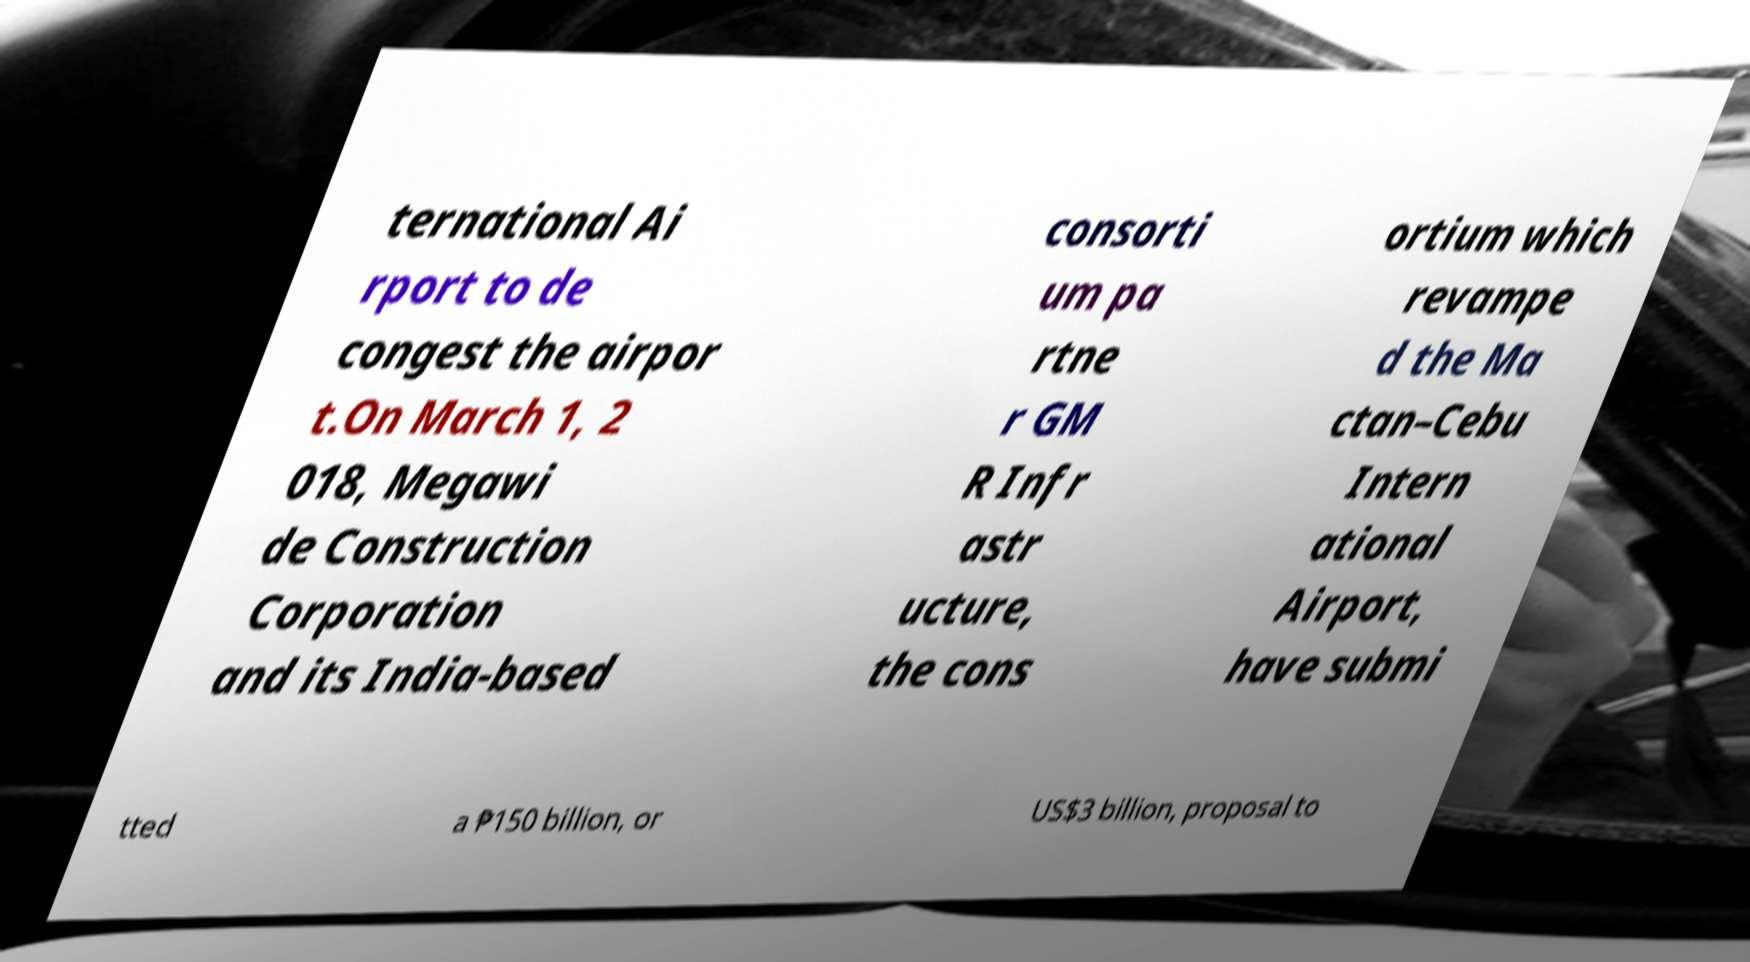Can you accurately transcribe the text from the provided image for me? ternational Ai rport to de congest the airpor t.On March 1, 2 018, Megawi de Construction Corporation and its India-based consorti um pa rtne r GM R Infr astr ucture, the cons ortium which revampe d the Ma ctan–Cebu Intern ational Airport, have submi tted a ₱150 billion, or US$3 billion, proposal to 